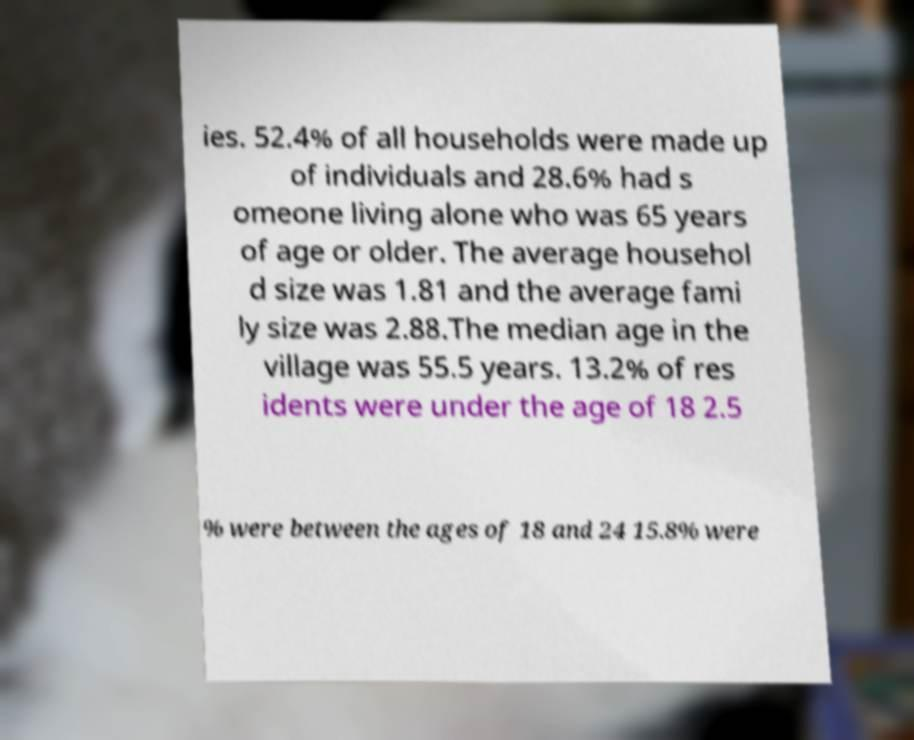Can you read and provide the text displayed in the image?This photo seems to have some interesting text. Can you extract and type it out for me? ies. 52.4% of all households were made up of individuals and 28.6% had s omeone living alone who was 65 years of age or older. The average househol d size was 1.81 and the average fami ly size was 2.88.The median age in the village was 55.5 years. 13.2% of res idents were under the age of 18 2.5 % were between the ages of 18 and 24 15.8% were 